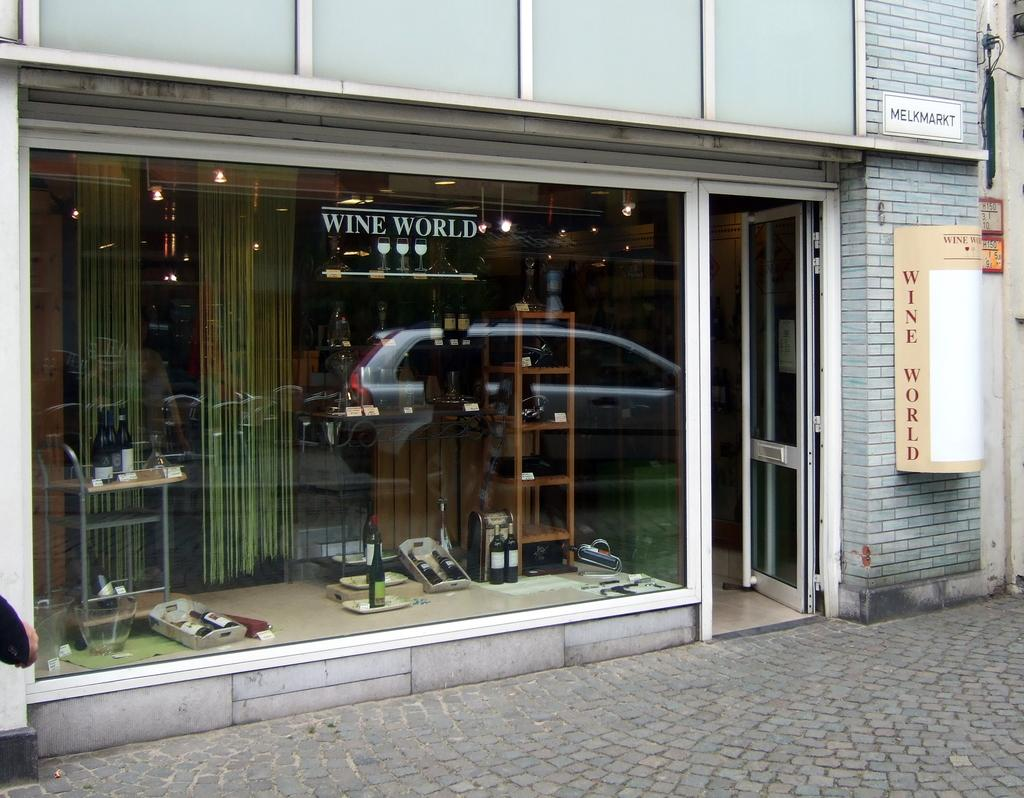What type of establishment is depicted in the image? There is a store in the image. What items can be seen inside the store? There are bottles and wooden objects inside the store. What material is used for the wall in front of the store? There is a glass wall in front of the store. What shape is the twig that is being used for a science experiment in the image? There is no twig or science experiment present in the image. 